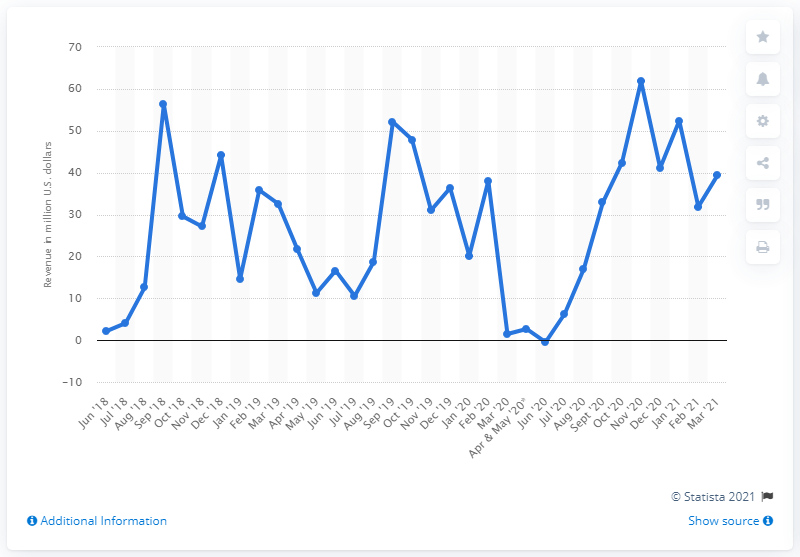Indicate a few pertinent items in this graphic. In March 2021, Nevada generated a total revenue of $39.35 million from sports betting. 